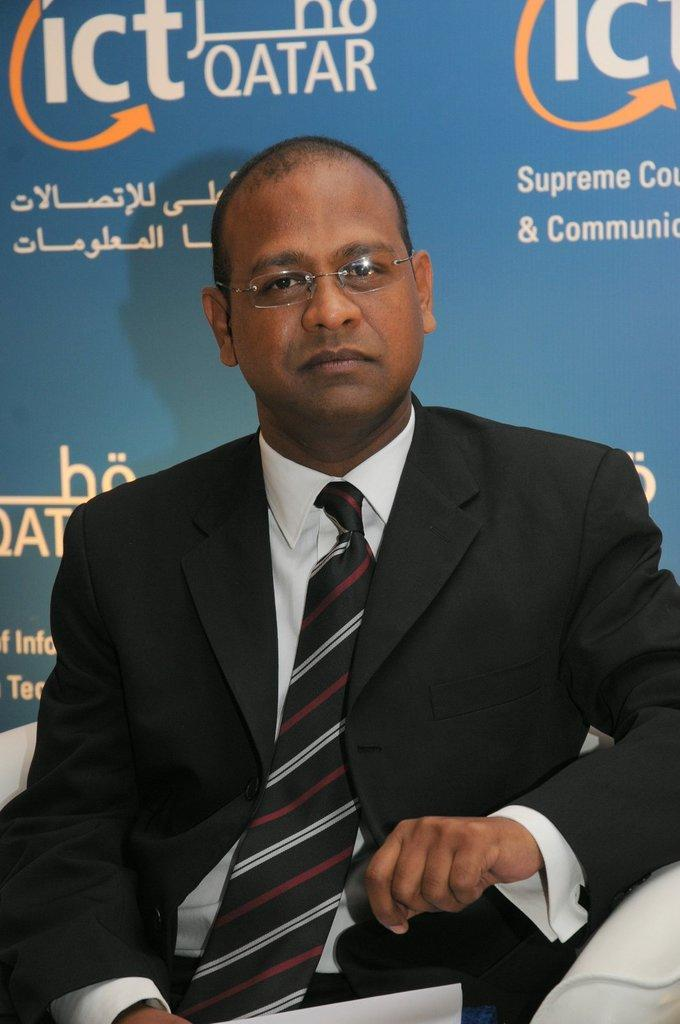What is the person in the image wearing? The person in the image is wearing a black suit. What is the person doing in the image? The person is sitting on a couch and holding a person (possibly a child or a doll). What can be seen in the background of the image? There is a banner in the background of the image. What is written on the banner? There is text on the banner. How many cats are visible in the image? There are no cats visible in the image. What is the level of pollution in the room depicted in the image? There is no information about pollution in the image, as it does not show any signs of pollution or environmental factors. 